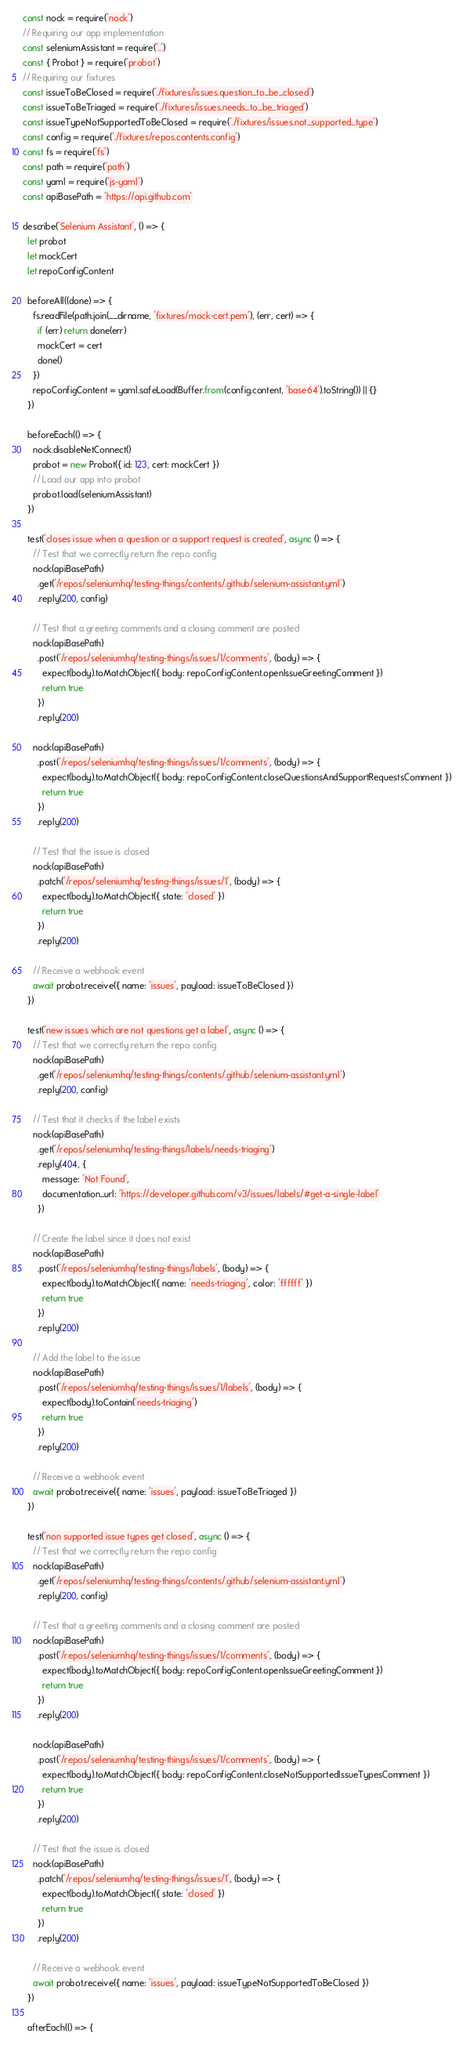<code> <loc_0><loc_0><loc_500><loc_500><_JavaScript_>const nock = require('nock')
// Requiring our app implementation
const seleniumAssistant = require('..')
const { Probot } = require('probot')
// Requiring our fixtures
const issueToBeClosed = require('./fixtures/issues.question_to_be_closed')
const issueToBeTriaged = require('./fixtures/issues.needs_to_be_triaged')
const issueTypeNotSupportedToBeClosed = require('./fixtures/issues.not_supported_type')
const config = require('./fixtures/repos.contents.config')
const fs = require('fs')
const path = require('path')
const yaml = require('js-yaml')
const apiBasePath = 'https://api.github.com'

describe('Selenium Assistant', () => {
  let probot
  let mockCert
  let repoConfigContent

  beforeAll((done) => {
    fs.readFile(path.join(__dirname, 'fixtures/mock-cert.pem'), (err, cert) => {
      if (err) return done(err)
      mockCert = cert
      done()
    })
    repoConfigContent = yaml.safeLoad(Buffer.from(config.content, 'base64').toString()) || {}
  })

  beforeEach(() => {
    nock.disableNetConnect()
    probot = new Probot({ id: 123, cert: mockCert })
    // Load our app into probot
    probot.load(seleniumAssistant)
  })

  test('closes issue when a question or a support request is created', async () => {
    // Test that we correctly return the repo config
    nock(apiBasePath)
      .get('/repos/seleniumhq/testing-things/contents/.github/selenium-assistant.yml')
      .reply(200, config)

    // Test that a greeting comments and a closing comment are posted
    nock(apiBasePath)
      .post('/repos/seleniumhq/testing-things/issues/1/comments', (body) => {
        expect(body).toMatchObject({ body: repoConfigContent.openIssueGreetingComment })
        return true
      })
      .reply(200)

    nock(apiBasePath)
      .post('/repos/seleniumhq/testing-things/issues/1/comments', (body) => {
        expect(body).toMatchObject({ body: repoConfigContent.closeQuestionsAndSupportRequestsComment })
        return true
      })
      .reply(200)

    // Test that the issue is closed
    nock(apiBasePath)
      .patch('/repos/seleniumhq/testing-things/issues/1', (body) => {
        expect(body).toMatchObject({ state: 'closed' })
        return true
      })
      .reply(200)

    // Receive a webhook event
    await probot.receive({ name: 'issues', payload: issueToBeClosed })
  })

  test('new issues which are not questions get a label', async () => {
    // Test that we correctly return the repo config
    nock(apiBasePath)
      .get('/repos/seleniumhq/testing-things/contents/.github/selenium-assistant.yml')
      .reply(200, config)

    // Test that it checks if the label exists
    nock(apiBasePath)
      .get('/repos/seleniumhq/testing-things/labels/needs-triaging')
      .reply(404, {
        message: 'Not Found',
        documentation_url: 'https://developer.github.com/v3/issues/labels/#get-a-single-label'
      })

    // Create the label since it does not exist
    nock(apiBasePath)
      .post('/repos/seleniumhq/testing-things/labels', (body) => {
        expect(body).toMatchObject({ name: 'needs-triaging', color: 'ffffff' })
        return true
      })
      .reply(200)

    // Add the label to the issue
    nock(apiBasePath)
      .post('/repos/seleniumhq/testing-things/issues/1/labels', (body) => {
        expect(body).toContain('needs-triaging')
        return true
      })
      .reply(200)

    // Receive a webhook event
    await probot.receive({ name: 'issues', payload: issueToBeTriaged })
  })

  test('non supported issue types get closed', async () => {
    // Test that we correctly return the repo config
    nock(apiBasePath)
      .get('/repos/seleniumhq/testing-things/contents/.github/selenium-assistant.yml')
      .reply(200, config)

    // Test that a greeting comments and a closing comment are posted
    nock(apiBasePath)
      .post('/repos/seleniumhq/testing-things/issues/1/comments', (body) => {
        expect(body).toMatchObject({ body: repoConfigContent.openIssueGreetingComment })
        return true
      })
      .reply(200)

    nock(apiBasePath)
      .post('/repos/seleniumhq/testing-things/issues/1/comments', (body) => {
        expect(body).toMatchObject({ body: repoConfigContent.closeNotSupportedIssueTypesComment })
        return true
      })
      .reply(200)

    // Test that the issue is closed
    nock(apiBasePath)
      .patch('/repos/seleniumhq/testing-things/issues/1', (body) => {
        expect(body).toMatchObject({ state: 'closed' })
        return true
      })
      .reply(200)

    // Receive a webhook event
    await probot.receive({ name: 'issues', payload: issueTypeNotSupportedToBeClosed })
  })

  afterEach(() => {</code> 